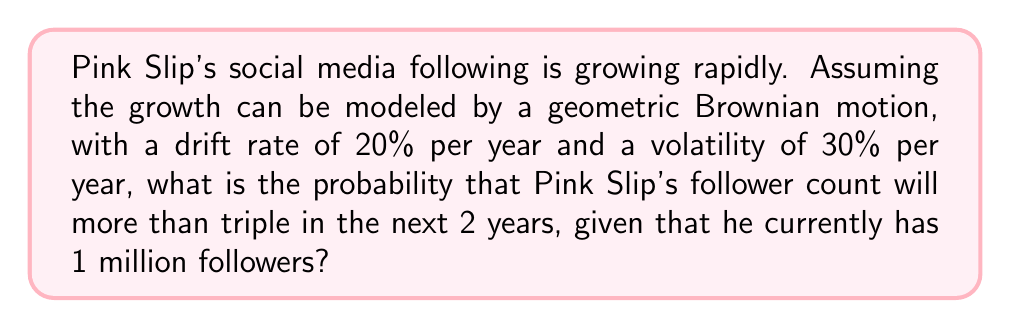Could you help me with this problem? Let's approach this step-by-step:

1) The geometric Brownian motion for Pink Slip's follower count $S_t$ can be described by the stochastic differential equation:

   $$dS_t = \mu S_t dt + \sigma S_t dW_t$$

   where $\mu = 0.20$ (drift rate) and $\sigma = 0.30$ (volatility)

2) The solution to this SDE is:

   $$S_t = S_0 \exp\left(\left(\mu - \frac{\sigma^2}{2}\right)t + \sigma W_t\right)$$

   where $S_0 = 1,000,000$ (initial follower count)

3) We want to find $P(S_2 > 3S_0)$, where $t = 2$ years

4) Taking logs of both sides:

   $$\ln(S_2) > \ln(3S_0)$$
   $$\ln(S_0) + \left(\mu - \frac{\sigma^2}{2}\right)2 + \sigma W_2 > \ln(3) + \ln(S_0)$$

5) Simplifying:

   $$\left(\mu - \frac{\sigma^2}{2}\right)2 + \sigma W_2 > \ln(3)$$

6) $W_2$ follows a normal distribution $N(0,2)$. Let's standardize it:

   $$\frac{W_2}{\sqrt{2}} \sim N(0,1)$$

7) Rearranging the inequality:

   $$\frac{W_2}{\sqrt{2}} > \frac{\ln(3) - \left(\mu - \frac{\sigma^2}{2}\right)2}{\sigma\sqrt{2}}$$

8) Calculating the right-hand side:

   $$\frac{\ln(3) - \left(0.20 - \frac{0.30^2}{2}\right)2}{0.30\sqrt{2}} = -0.3067$$

9) The probability is then:

   $$P\left(\frac{W_2}{\sqrt{2}} > -0.3067\right) = 1 - \Phi(-0.3067) = \Phi(0.3067)$$

   where $\Phi$ is the standard normal cumulative distribution function

10) Using a standard normal table or calculator:

    $$\Phi(0.3067) \approx 0.6205$$

Therefore, the probability that Pink Slip's follower count will more than triple in 2 years is approximately 0.6205 or 62.05%.
Answer: 0.6205 